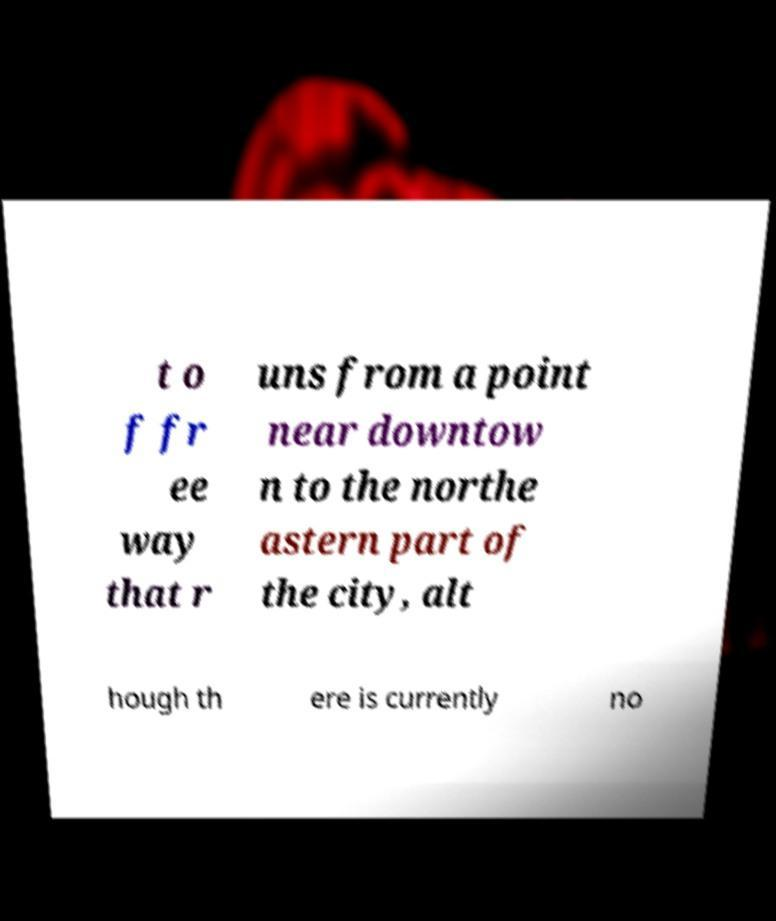For documentation purposes, I need the text within this image transcribed. Could you provide that? t o f fr ee way that r uns from a point near downtow n to the northe astern part of the city, alt hough th ere is currently no 